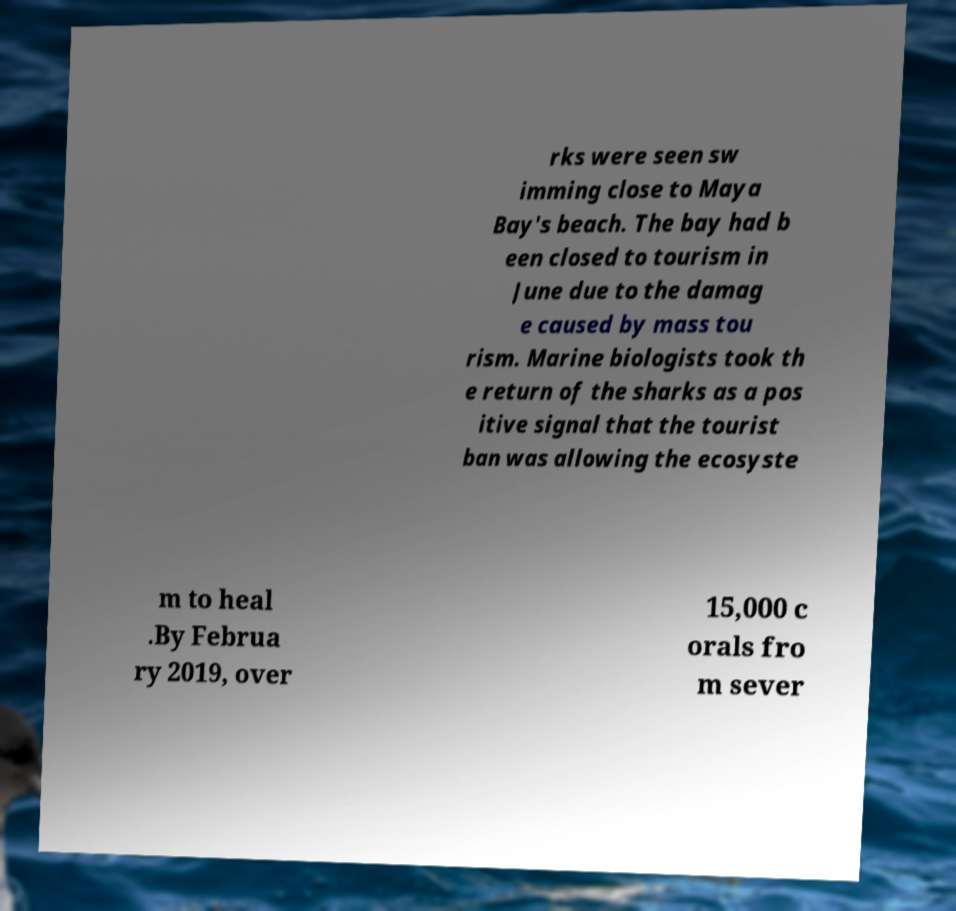Could you extract and type out the text from this image? rks were seen sw imming close to Maya Bay's beach. The bay had b een closed to tourism in June due to the damag e caused by mass tou rism. Marine biologists took th e return of the sharks as a pos itive signal that the tourist ban was allowing the ecosyste m to heal .By Februa ry 2019, over 15,000 c orals fro m sever 